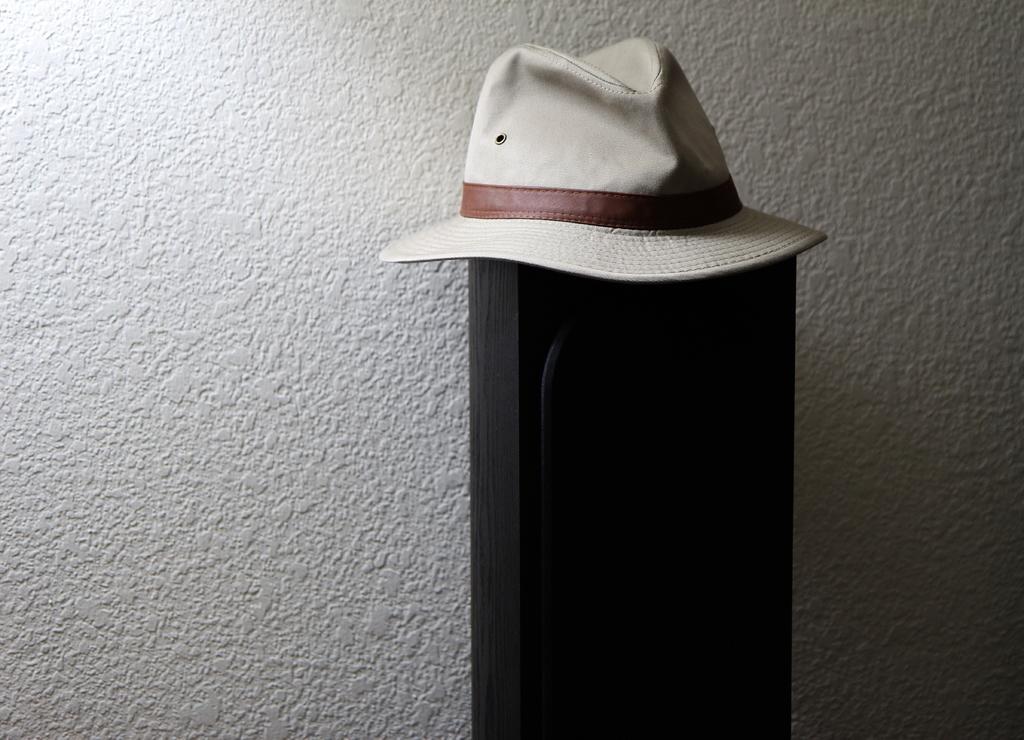Could you give a brief overview of what you see in this image? In this image I can see there is a wooden table and there is a cap placed on it. 